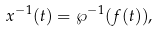Convert formula to latex. <formula><loc_0><loc_0><loc_500><loc_500>x ^ { - 1 } ( t ) = \wp ^ { - 1 } ( f ( t ) ) ,</formula> 